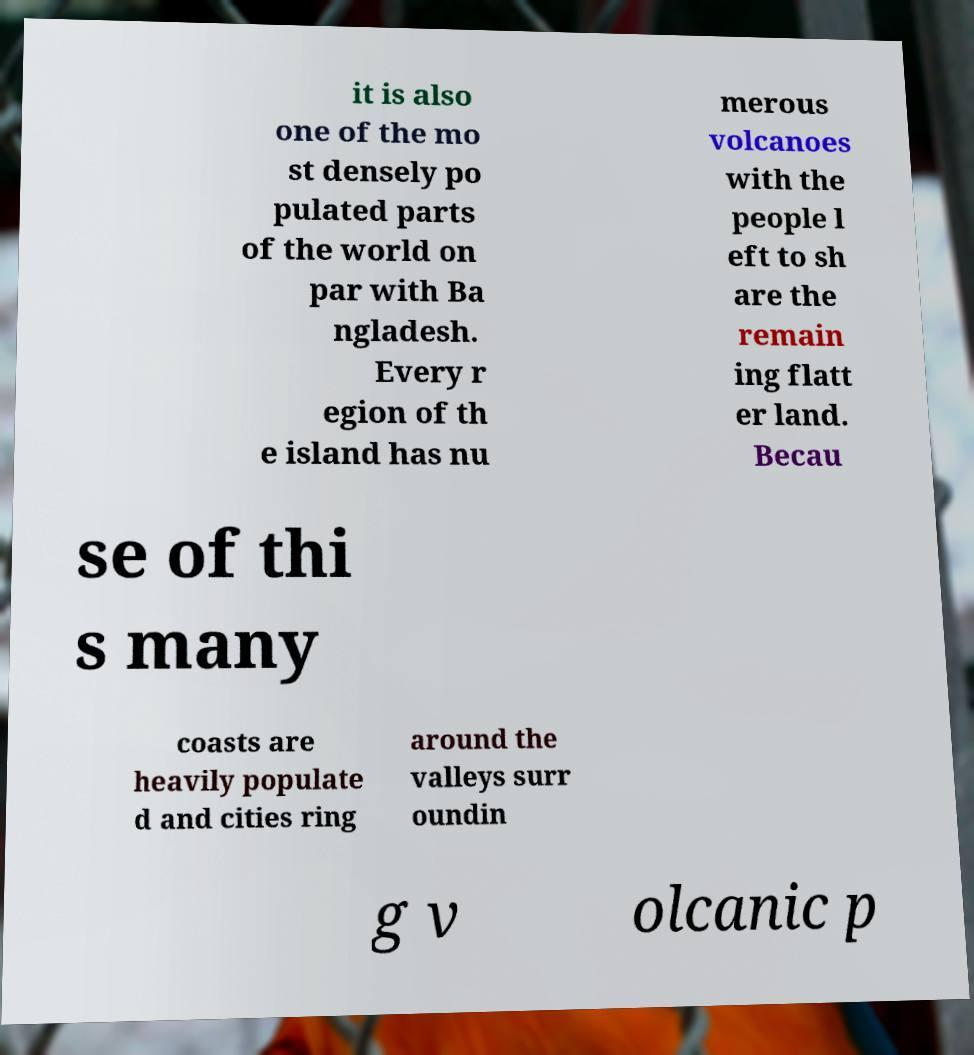Could you assist in decoding the text presented in this image and type it out clearly? it is also one of the mo st densely po pulated parts of the world on par with Ba ngladesh. Every r egion of th e island has nu merous volcanoes with the people l eft to sh are the remain ing flatt er land. Becau se of thi s many coasts are heavily populate d and cities ring around the valleys surr oundin g v olcanic p 